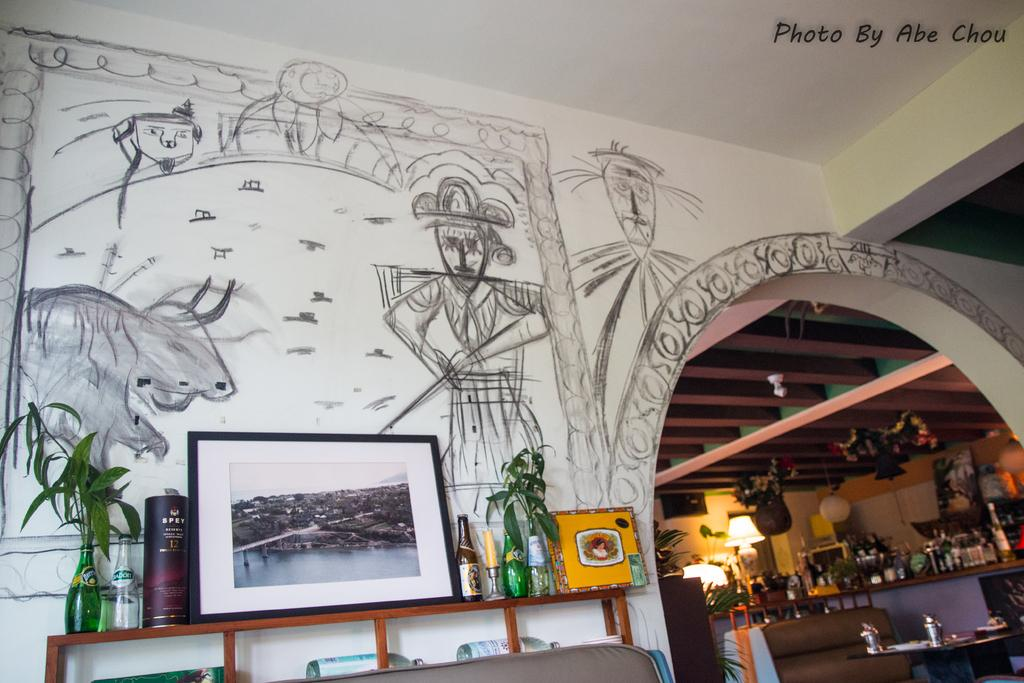What type of space is depicted in the image? There is a room in the image. What can be seen on the wall in the room? There are many things on the wall in the room. Can you describe the design near the wall in the room? There is a design near the wall in the room. What piece of furniture is present in the room? There is a table in the room. What items are on the table in the room? There are many things on the table in the room. What is the name of the fruit that is being produced on the table in the image? There is no fruit being produced on the table in the image. In which direction is the room facing in the image? The direction the room is facing cannot be determined from the image. 